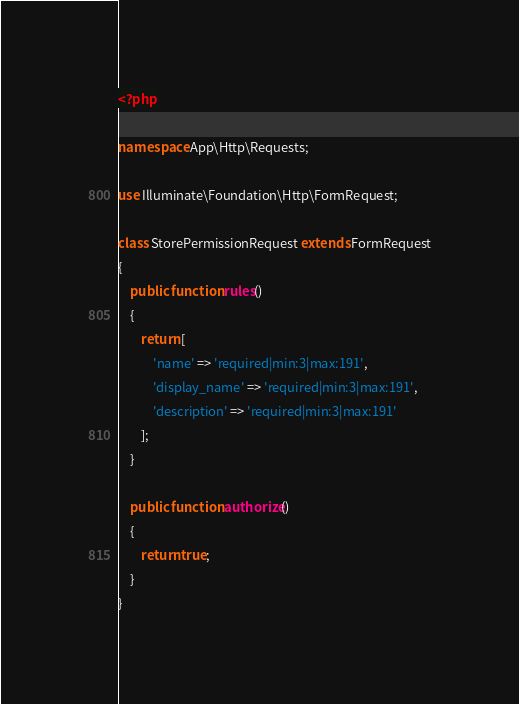Convert code to text. <code><loc_0><loc_0><loc_500><loc_500><_PHP_><?php

namespace App\Http\Requests;

use Illuminate\Foundation\Http\FormRequest;

class StorePermissionRequest extends FormRequest
{
    public function rules()
    {
        return [
            'name' => 'required|min:3|max:191',
            'display_name' => 'required|min:3|max:191',
            'description' => 'required|min:3|max:191'
        ];
    }

    public function authorize()
    {
        return true;
    }
}
</code> 